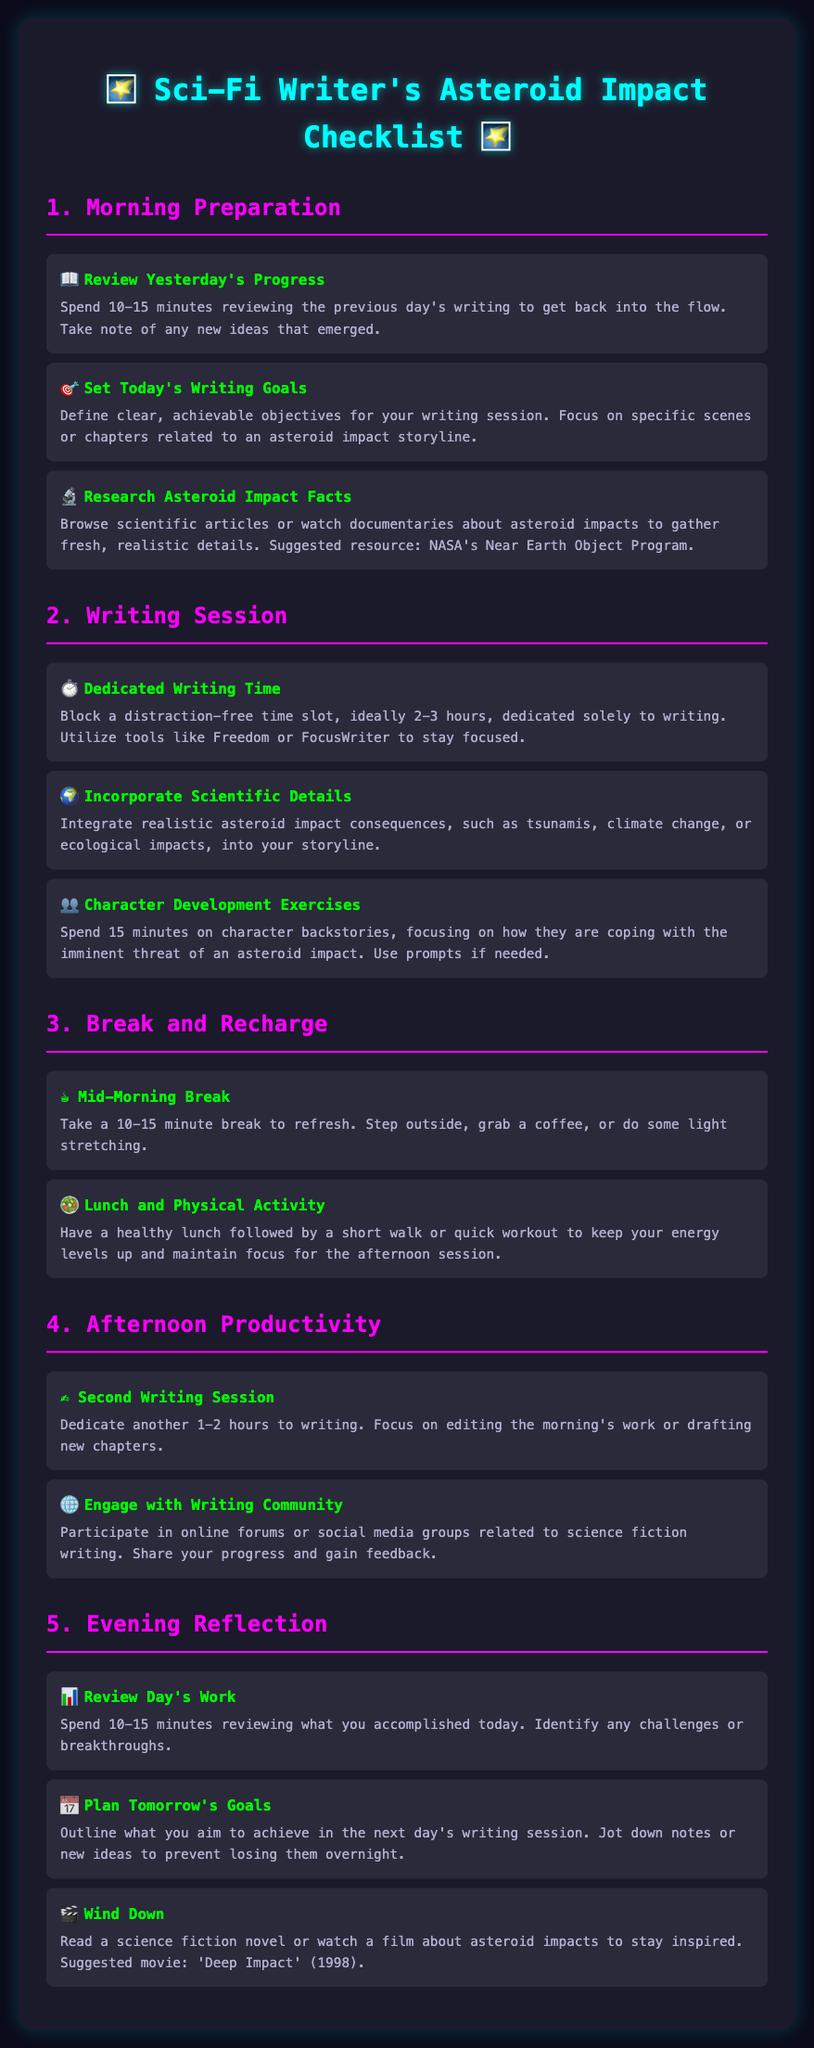What is the title of the checklist? The title of the checklist is prominently displayed at the top of the document.
Answer: Sci-Fi Writer's Asteroid Impact Checklist How many sections are in the checklist? The document consists of five distinct sections detailing various aspects of the writing routine.
Answer: 5 What task is suggested for the morning preparation regarding character backstories? The document outlines specific tasks within each section, including one related to character backstories in the morning prep.
Answer: Character Development Exercises What is the duration of the dedicated writing time suggested in the writing session? The writing session includes a task with a recommended time block for writing.
Answer: 2-3 hours What should be done during the mid-morning break? This section outlines a break that includes refreshment activities.
Answer: Step outside, grab a coffee, or do some light stretching How long should the evening reflection review take? The document specifies a time recommendation for reflecting on the day's work.
Answer: 10-15 minutes What activity is recommended for winding down in the evening? The document suggests an inspiring activity that involves reading or watching a film.
Answer: Read a science fiction novel or watch a film What is the purpose of engaging with the writing community? The document implies the reason for interacting with the community during the afternoon productivity section.
Answer: Share your progress and gain feedback What specific type of documentaries should be researched in the morning preparation? The checklist recommends a particular type of resource for research.
Answer: Asteroid Impact Facts 